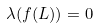<formula> <loc_0><loc_0><loc_500><loc_500>\lambda ( f ( L ) ) = 0</formula> 